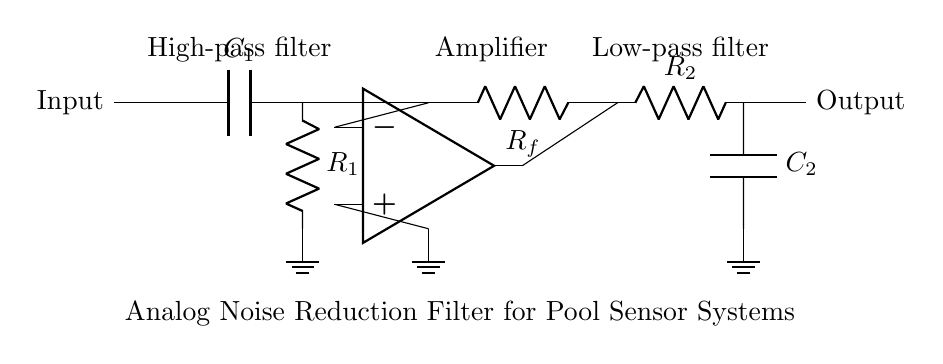What type of filter is used at the input? The circuit includes a capacitor and a resistor at the input, which together form a high-pass filter that allows high frequencies to pass while attenuating low frequencies.
Answer: High-pass filter What is the component at the output of the op-amp? The output of the op-amp goes into a resistor, which feeds into the low-pass filter stage of the circuit. This allows the op-amp output to be controlled by the resistive feedback.
Answer: Resistor Which component acts as the amplifier in the circuit? The operational amplifier (op-amp) in the circuit is used to amplify the input signal, enhancing the signal level before it's further processed by the low-pass filter.
Answer: Op-amp What is the role of R_f in this circuit? Resistor R_f is used for feedback in the op-amp configuration, which influences the gain of the amplifier. By adjusting R_f, one can control how much of the output signal is fed back into the inverting input.
Answer: Feedback How many capacitors are in the circuit? The circuit comprises two capacitors, C_1 and C_2, which are used in the high-pass and low-pass filter stages, respectively, for noise reduction.
Answer: Two capacitors What frequency response does the low-pass filter provide? The low-pass filter allows frequencies below a certain cutoff frequency to pass while attenuating those above this frequency, which is essential for minimizing high-frequency noise in the sensor signal.
Answer: Low-pass filter What is the function of the circuit as a whole? This analog filter circuit is designed to reduce noise from pool sensor systems, allowing for cleaner and more accurate readings by filtering out unwanted signal components.
Answer: Noise reduction filter 